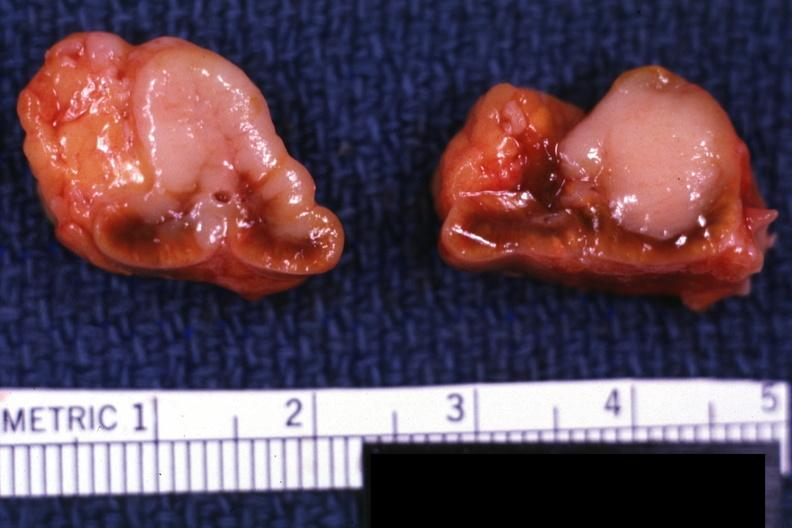s primary slide 6911 and bone metastatsis?
Answer the question using a single word or phrase. Yes 